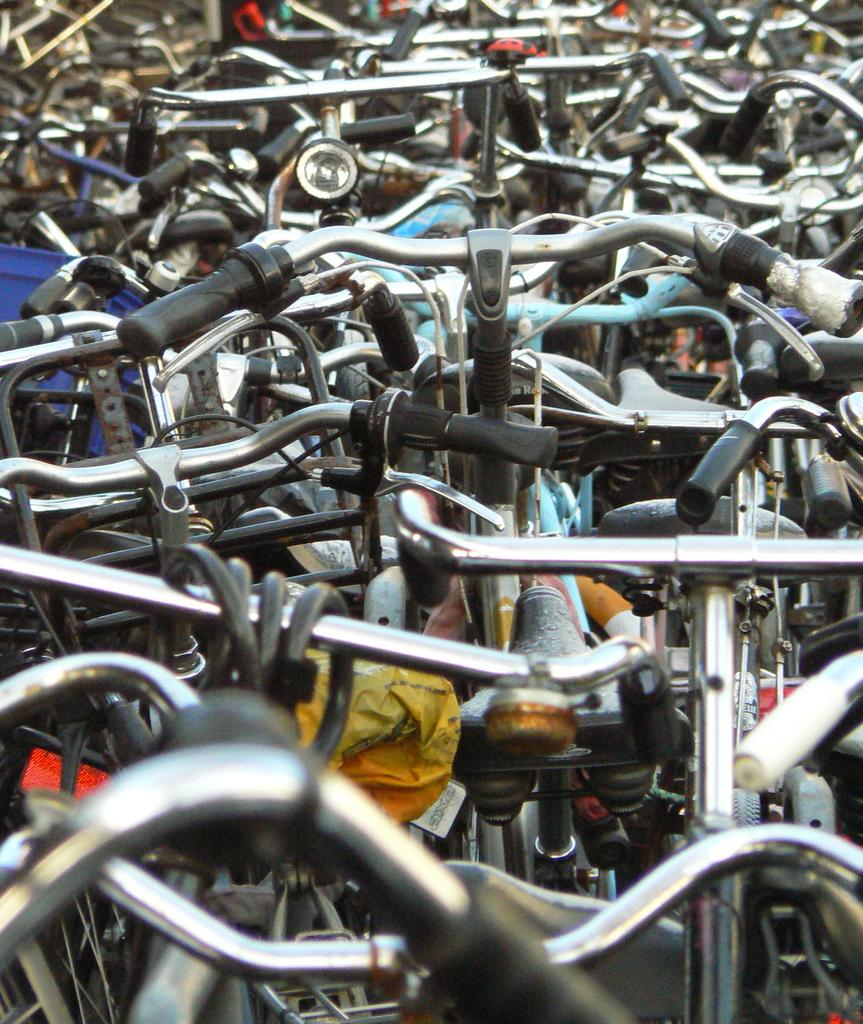What type of vehicles are present in the image? There are many bicycles in the image. What are the main features of the bicycles? The bicycles have handles, pedals, and wheels. Are there any additional features on some of the bicycles? Some bicycles have horns. How many pigs are riding the bicycles in the image? There are no pigs present in the image; it features bicycles. What type of growth can be seen on the bicycles in the image? There is no growth visible on the bicycles in the image. 